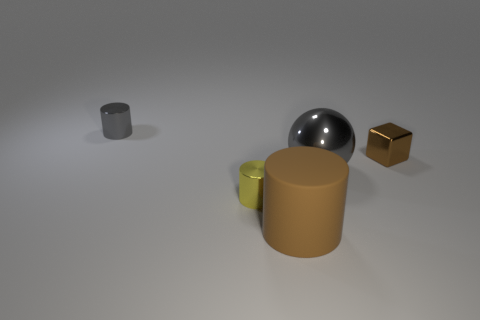Add 1 cubes. How many objects exist? 6 Subtract all cubes. How many objects are left? 4 Add 2 big gray metallic cubes. How many big gray metallic cubes exist? 2 Subtract 0 cyan cylinders. How many objects are left? 5 Subtract all large yellow metal cylinders. Subtract all gray metal cylinders. How many objects are left? 4 Add 1 metal cylinders. How many metal cylinders are left? 3 